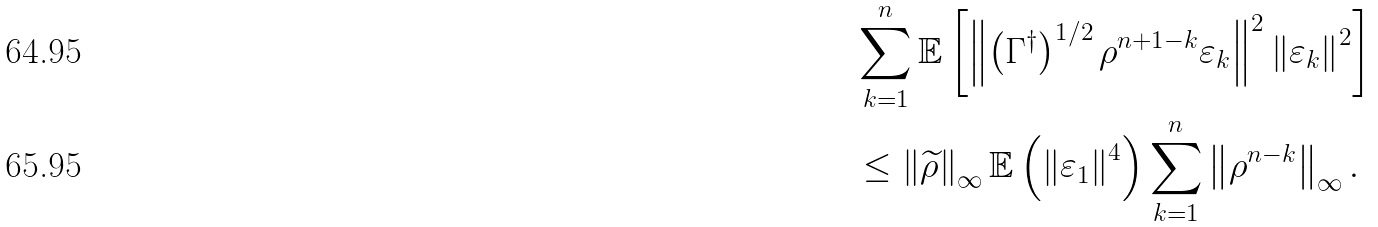<formula> <loc_0><loc_0><loc_500><loc_500>& \sum _ { k = 1 } ^ { n } \mathbb { E } \left [ \left \| \left ( \Gamma ^ { \dagger } \right ) ^ { 1 / 2 } \rho ^ { n + 1 - k } \varepsilon _ { k } \right \| ^ { 2 } \left \| \varepsilon _ { k } \right \| ^ { 2 } \right ] \\ & \leq \left \| \widetilde { \rho } \right \| _ { \infty } \mathbb { E } \left ( \left \| \varepsilon _ { 1 } \right \| ^ { 4 } \right ) \sum _ { k = 1 } ^ { n } \left \| \rho ^ { n - k } \right \| _ { \infty } .</formula> 